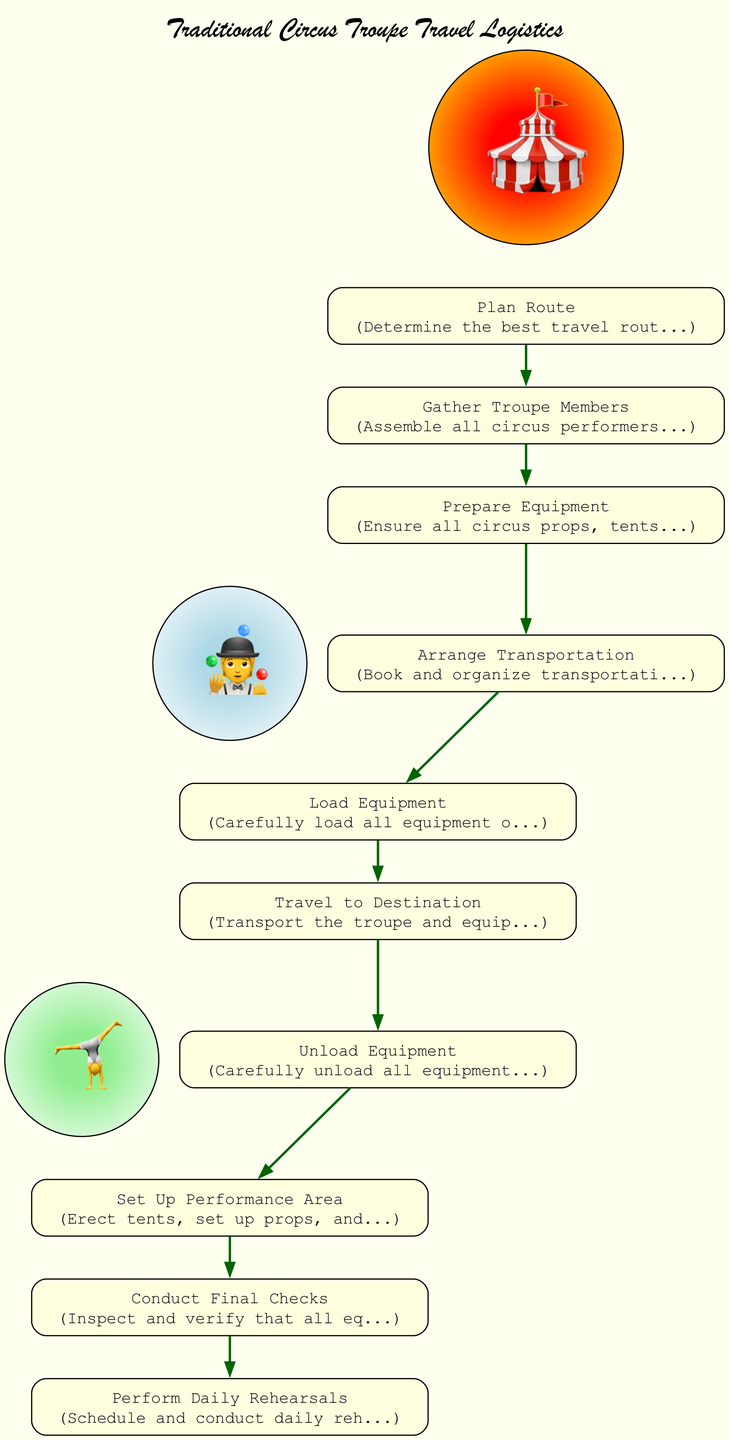What is the first activity in the diagram? The diagram starts with the first activity labeled "Plan Route," which is the initial node in the sequence of activities.
Answer: Plan Route How many activities are depicted in the diagram? There are 10 activities listed in the diagram, as evidenced by the number of nodes representing each individual activity related to travel logistics.
Answer: 10 What is the last activity before performing daily rehearsals? The last activity before "Perform Daily Rehearsals" is "Conduct Final Checks," which precedes the rehearsals in the workflow.
Answer: Conduct Final Checks What activity comes directly after "Unload Equipment"? The activity following "Unload Equipment" is "Set Up Performance Area," which is the next step in the outlined travel process.
Answer: Set Up Performance Area Which activity involves assembling circus performers and crew members? The activity that involves assembling circus performers and crew members is "Gather Troupe Members," as outlined in the flow of activities.
Answer: Gather Troupe Members What is the total number of transitions between activities? The diagram contains 9 transitions, connecting each of the activities to the subsequent step in the travel process.
Answer: 9 What activity must occur before arranging transportation? Prior to "Arrange Transportation," the activity that must occur is "Prepare Equipment," which sets up for the arrangement of transport.
Answer: Prepare Equipment Which two activities are linked by the transition from "Travel to Destination"? The two linked activities are "Travel to Destination," which transitions to "Unload Equipment," indicating the flow of the process.
Answer: Unload Equipment What is the primary purpose of the "Set Up Performance Area" activity? The primary purpose of the "Set Up Performance Area" activity is to erect tents and prepare the performance spaces according to traditional circus standards.
Answer: Erect tents and prepare performance areas 